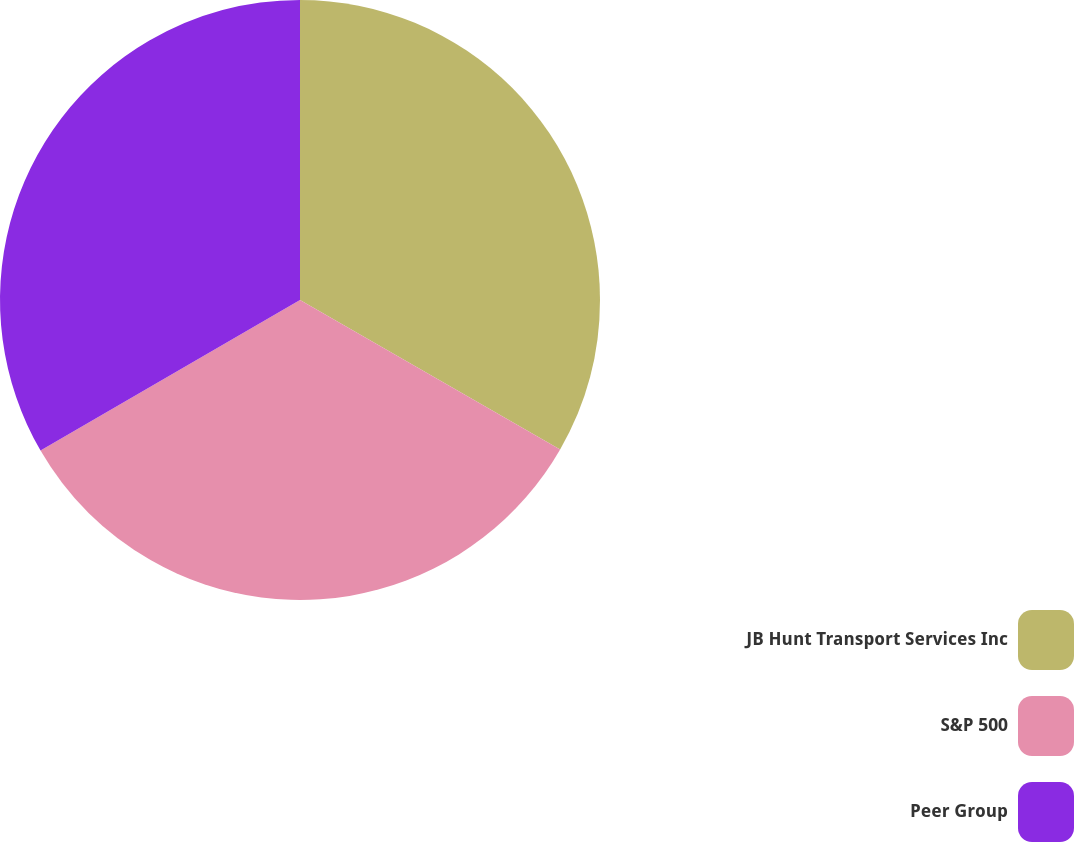Convert chart. <chart><loc_0><loc_0><loc_500><loc_500><pie_chart><fcel>JB Hunt Transport Services Inc<fcel>S&P 500<fcel>Peer Group<nl><fcel>33.3%<fcel>33.33%<fcel>33.37%<nl></chart> 